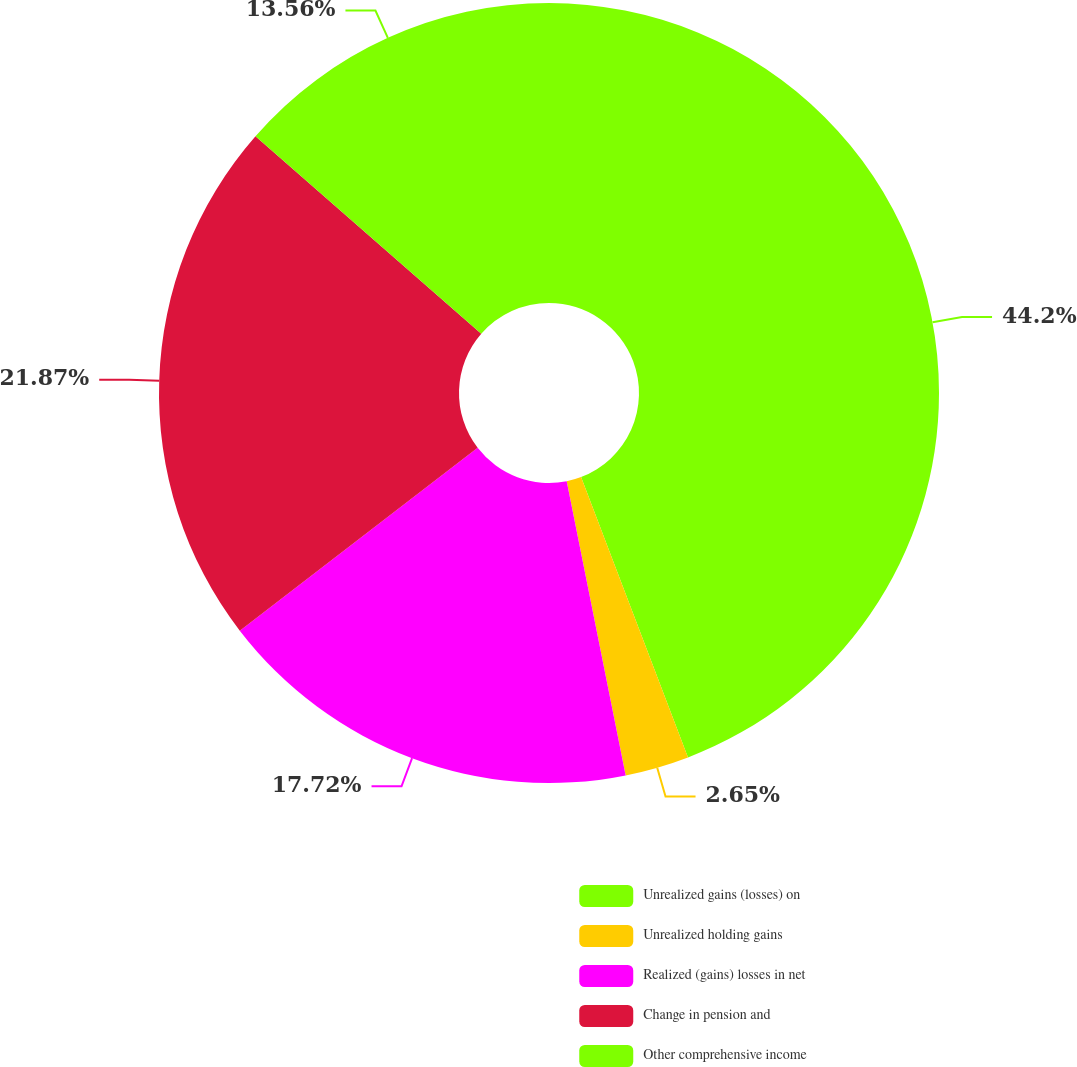<chart> <loc_0><loc_0><loc_500><loc_500><pie_chart><fcel>Unrealized gains (losses) on<fcel>Unrealized holding gains<fcel>Realized (gains) losses in net<fcel>Change in pension and<fcel>Other comprehensive income<nl><fcel>44.2%<fcel>2.65%<fcel>17.72%<fcel>21.87%<fcel>13.56%<nl></chart> 